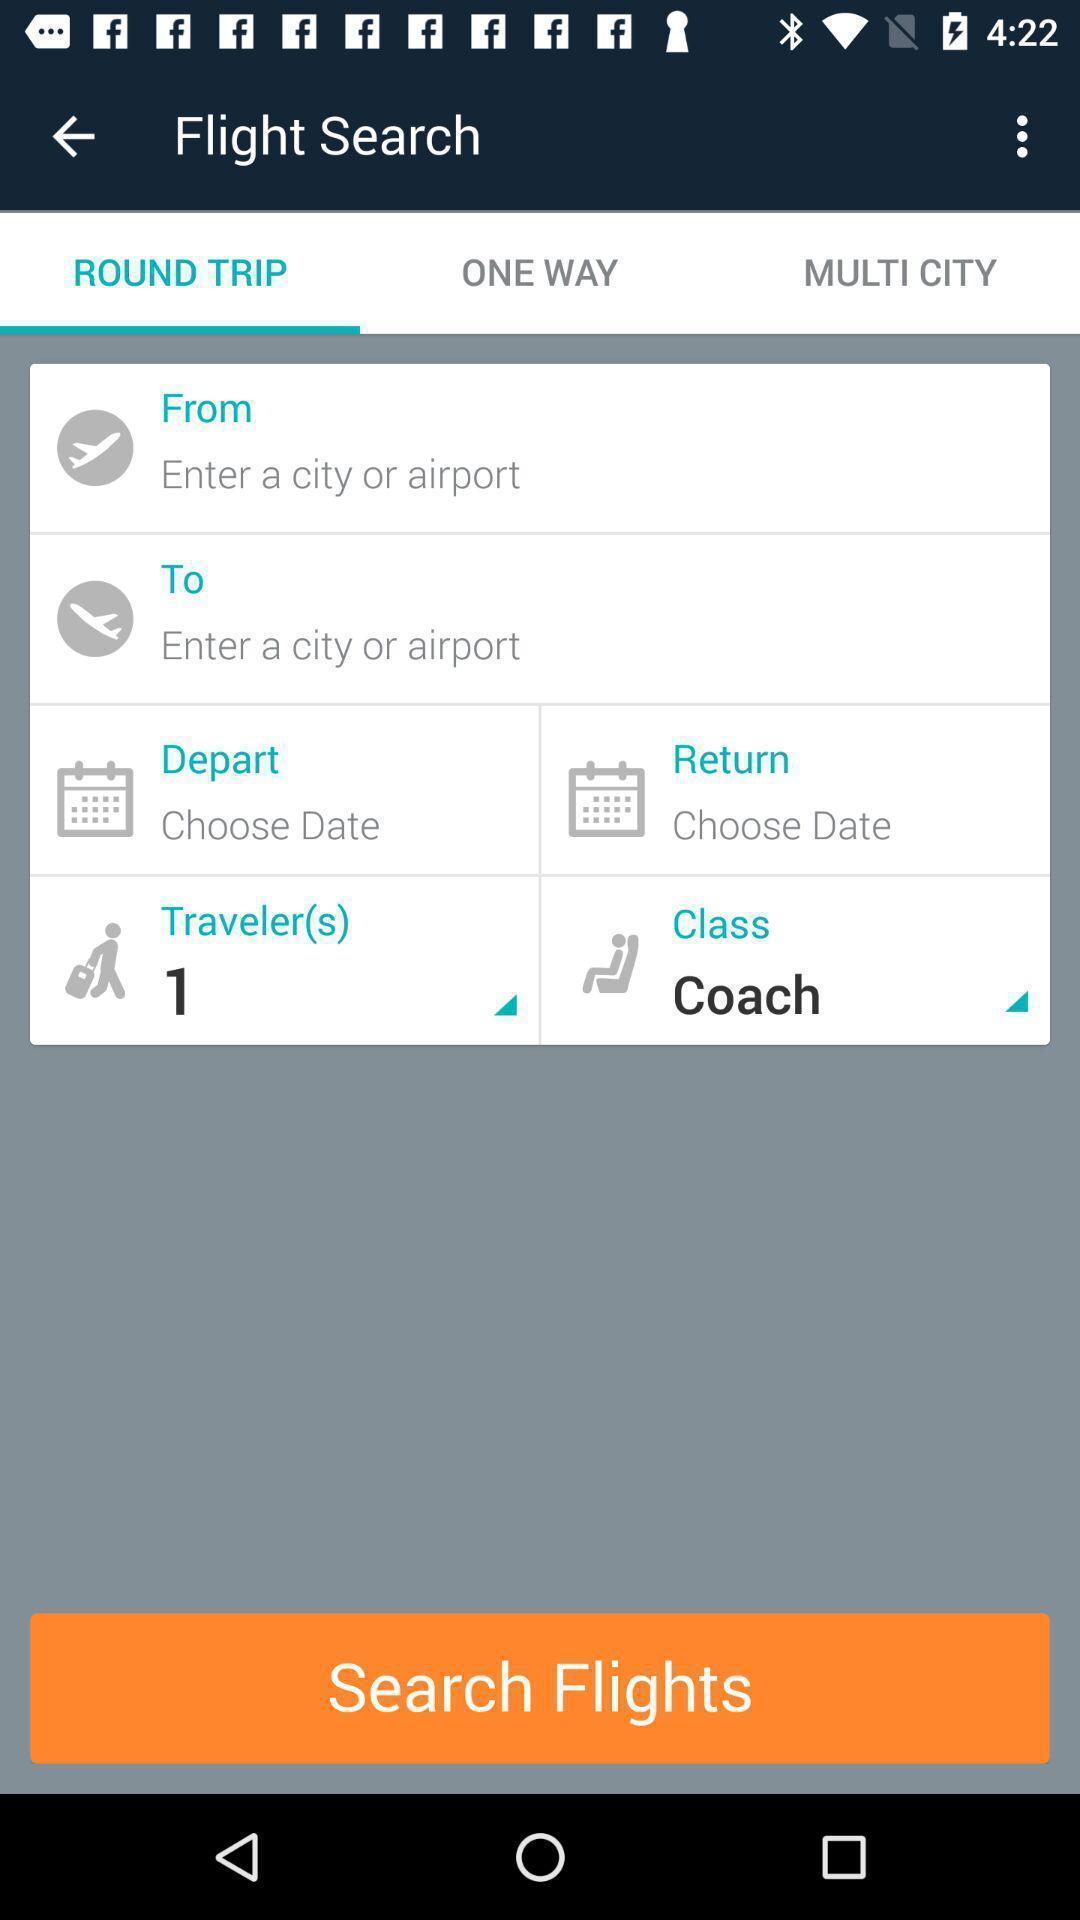What is the overall content of this screenshot? Social app for searching flights. 